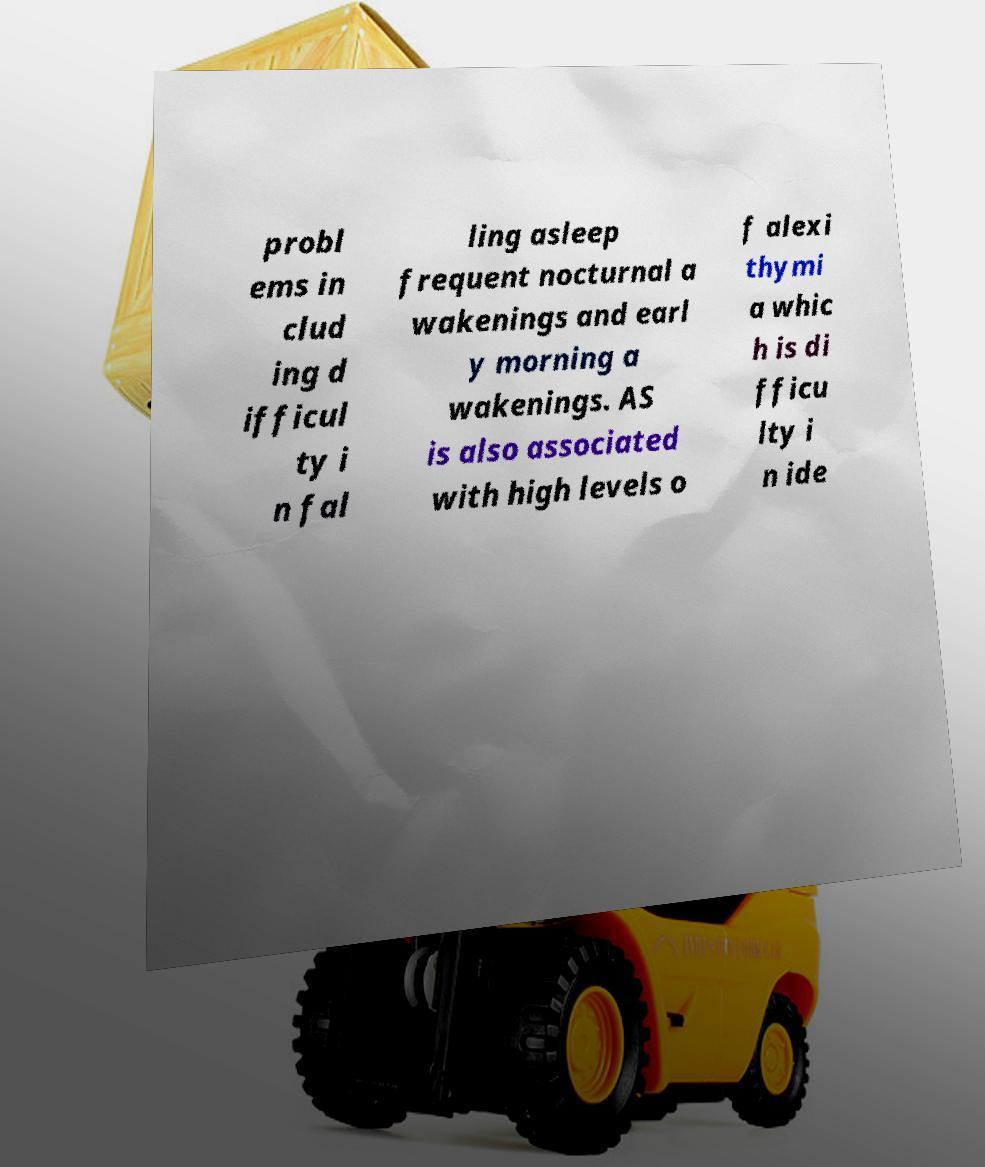For documentation purposes, I need the text within this image transcribed. Could you provide that? probl ems in clud ing d ifficul ty i n fal ling asleep frequent nocturnal a wakenings and earl y morning a wakenings. AS is also associated with high levels o f alexi thymi a whic h is di fficu lty i n ide 